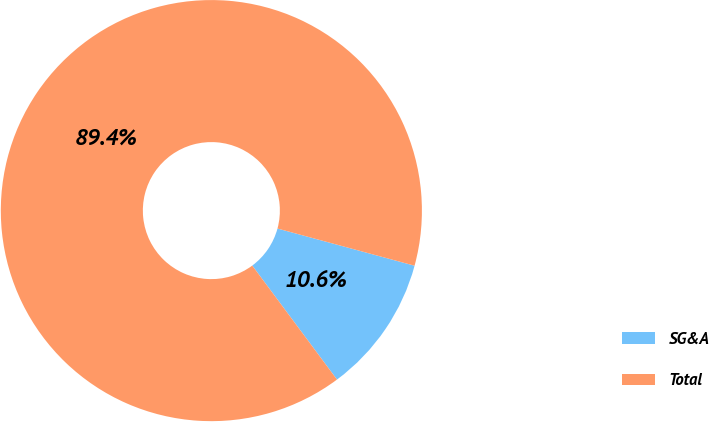<chart> <loc_0><loc_0><loc_500><loc_500><pie_chart><fcel>SG&A<fcel>Total<nl><fcel>10.61%<fcel>89.39%<nl></chart> 